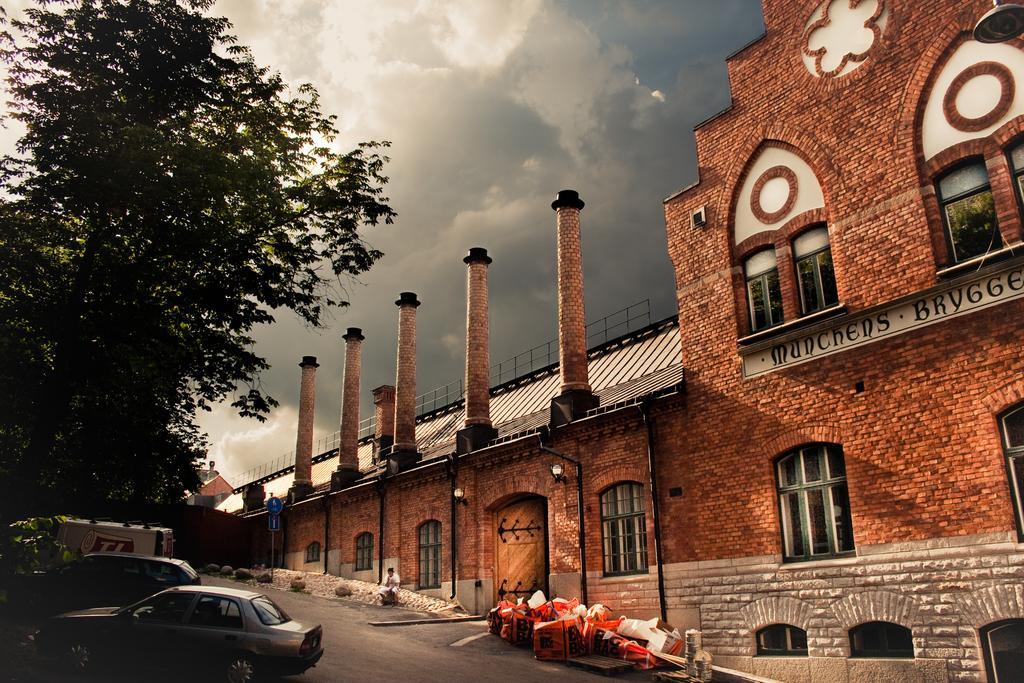Can you describe this image briefly? In this image, we can see a building, walls, glass windows, door, pillars, pipes, lights, board with text. On the right side of the image, we can see trees, pole with board. At the bottom of the image, we can see a person sitting on an object, vehicles on the road and few objects. In the background, there is the cloudy sky.  